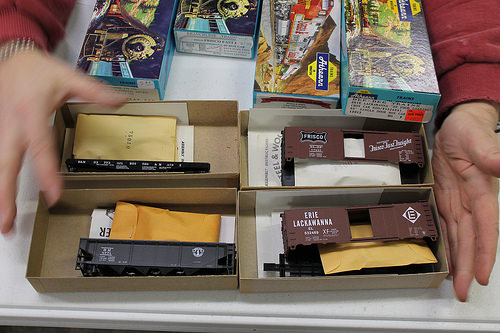<image>
Can you confirm if the toy train is above the toy train? No. The toy train is not positioned above the toy train. The vertical arrangement shows a different relationship. 